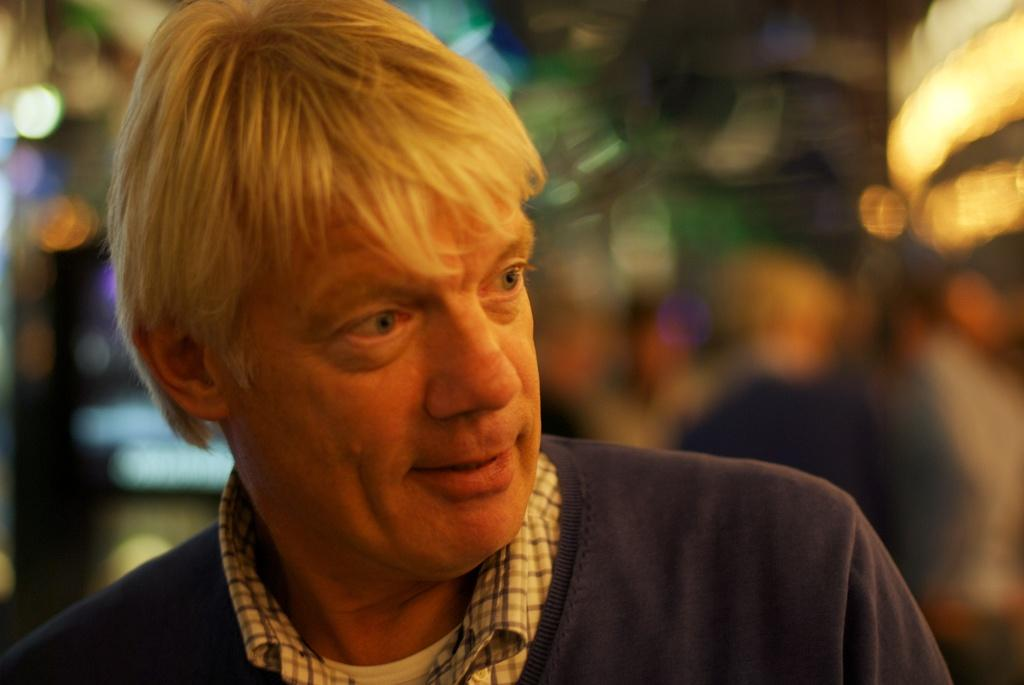Where was the image most likely taken? The image was likely taken outside. Can you describe the person in the foreground of the image? There is a person in the foreground of the image. What can be seen in the background of the image? There are lights visible in the background of the image. How would you describe the background of the image? The background of the image is blurry. Can you tell me how many rabbits are hopping on the sidewalk in the image? There are no rabbits or sidewalks present in the image. 